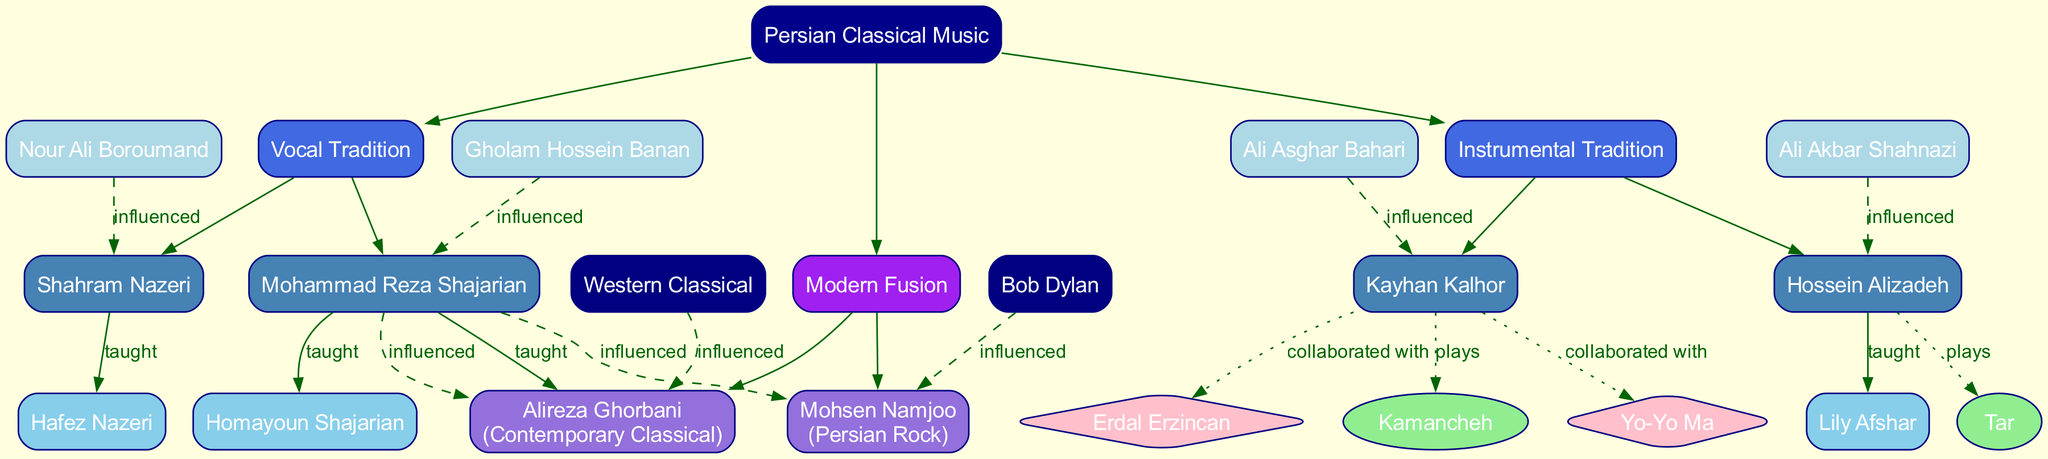What is the root of the family tree? The diagram shows "Persian Classical Music" as the topmost node, representing the main category.
Answer: Persian Classical Music How many branches are there in the diagram? By analyzing the branches emanating from the root node, there are two distinct branches: Vocal Tradition and Instrumental Tradition.
Answer: 2 Who is a student of Mohammad Reza Shajarian? The artist Mohammad Reza Shajarian has two students listed. One of them is Homayoun Shajarian.
Answer: Homayoun Shajarian Which instrument does Hossein Alizadeh play? The diagram specifies that Hossein Alizadeh is associated with the instrument "Tar." This is indicated within the node related to him.
Answer: Tar How is Mohsen Namjoo categorized in the diagram? The diagram categorizes Mohsen Namjoo under "Modern Fusion" and specifies his style as "Persian Rock." This is shown in his node.
Answer: Persian Rock Who influenced Kayhan Kalhor? Looking at the edges showing influences, Kayhan Kalhor is influenced by Ali Asghar Bahari.
Answer: Ali Asghar Bahari What type of collaborations are associated with Kayhan Kalhor? In exploring the collaborations linked to Kayhan Kalhor, the diagram indicates he has collaborated with Yo-Yo Ma and Erdal Erzincan.
Answer: Yo-Yo Ma, Erdal Erzincan How many students does Shahram Nazeri have? The node associated with Shahram Nazeri lists only one student, Hafez Nazeri.
Answer: 1 Which artists influenced Alireza Ghorbani? The influences on Alireza Ghorbani noted in the diagram include Mohammad Reza Shajarian and Western Classical music.
Answer: Mohammad Reza Shajarian, Western Classical What is the relationship between Mohammad Reza Shajarian and Alireza Ghorbani? There is a dashed edge linking Mohammad Reza Shajarian to Alireza Ghorbani, indicating that Ghorbani has been influenced by Shajarian.
Answer: influenced 